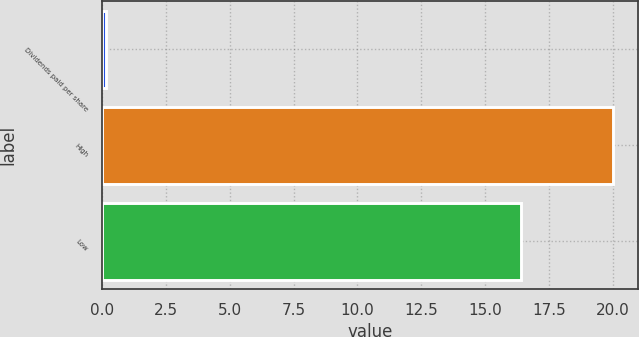Convert chart to OTSL. <chart><loc_0><loc_0><loc_500><loc_500><bar_chart><fcel>Dividends paid per share<fcel>High<fcel>Low<nl><fcel>0.15<fcel>20<fcel>16.41<nl></chart> 